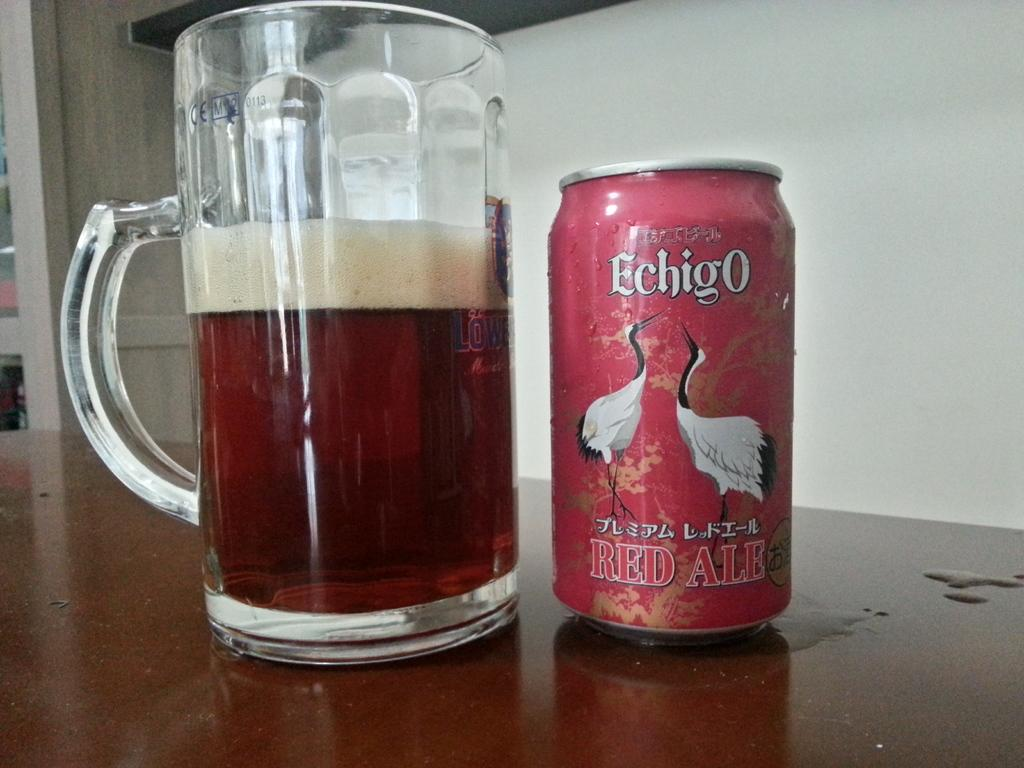<image>
Relay a brief, clear account of the picture shown. A can of Echigo red ale next to a mug of ale. 